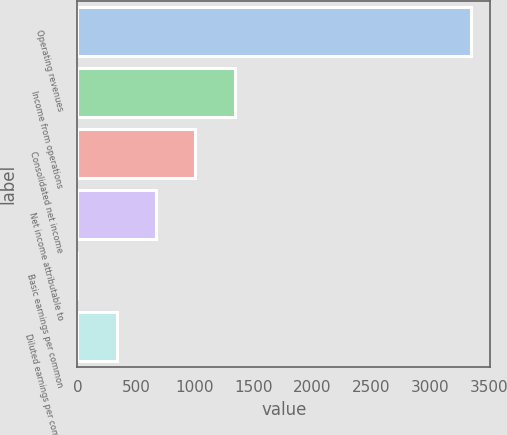<chart> <loc_0><loc_0><loc_500><loc_500><bar_chart><fcel>Operating revenues<fcel>Income from operations<fcel>Consolidated net income<fcel>Net income attributable to<fcel>Basic earnings per common<fcel>Diluted earnings per common<nl><fcel>3347<fcel>1339.1<fcel>1004.45<fcel>669.8<fcel>0.5<fcel>335.15<nl></chart> 